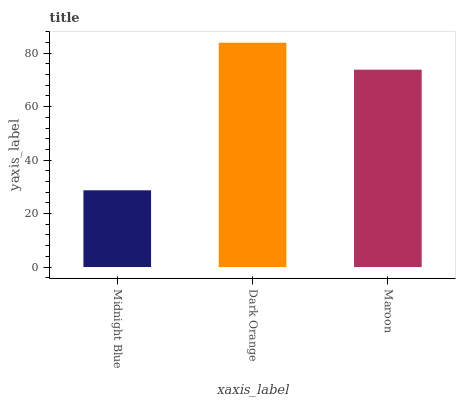Is Midnight Blue the minimum?
Answer yes or no. Yes. Is Dark Orange the maximum?
Answer yes or no. Yes. Is Maroon the minimum?
Answer yes or no. No. Is Maroon the maximum?
Answer yes or no. No. Is Dark Orange greater than Maroon?
Answer yes or no. Yes. Is Maroon less than Dark Orange?
Answer yes or no. Yes. Is Maroon greater than Dark Orange?
Answer yes or no. No. Is Dark Orange less than Maroon?
Answer yes or no. No. Is Maroon the high median?
Answer yes or no. Yes. Is Maroon the low median?
Answer yes or no. Yes. Is Midnight Blue the high median?
Answer yes or no. No. Is Midnight Blue the low median?
Answer yes or no. No. 